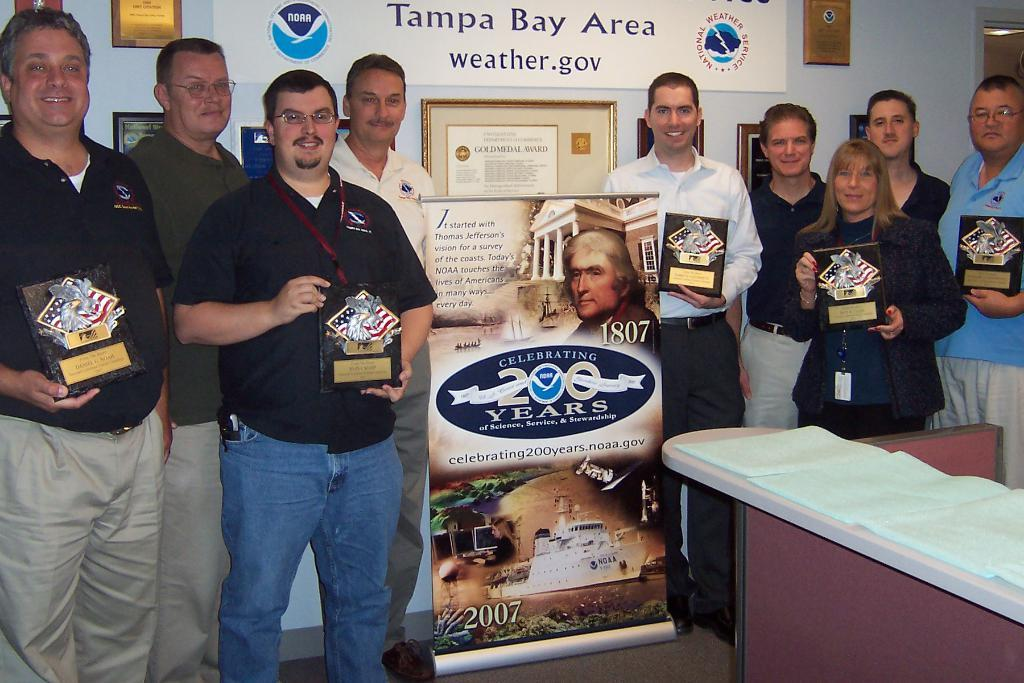Provide a one-sentence caption for the provided image. Several people stand in front of a board that says Tampa Bay Area weather.gov holding plaques. 